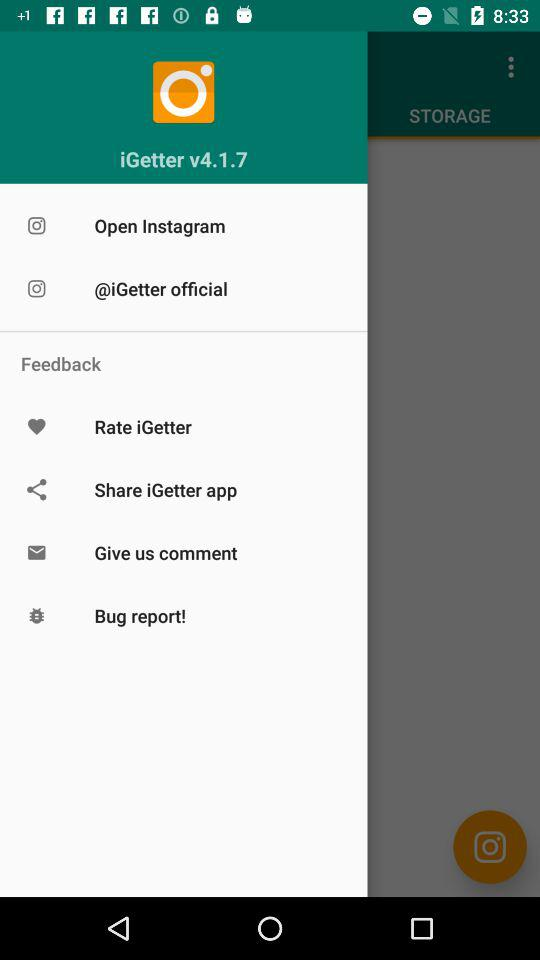What is the version of "iGetter"? The version is v4.1.7. 